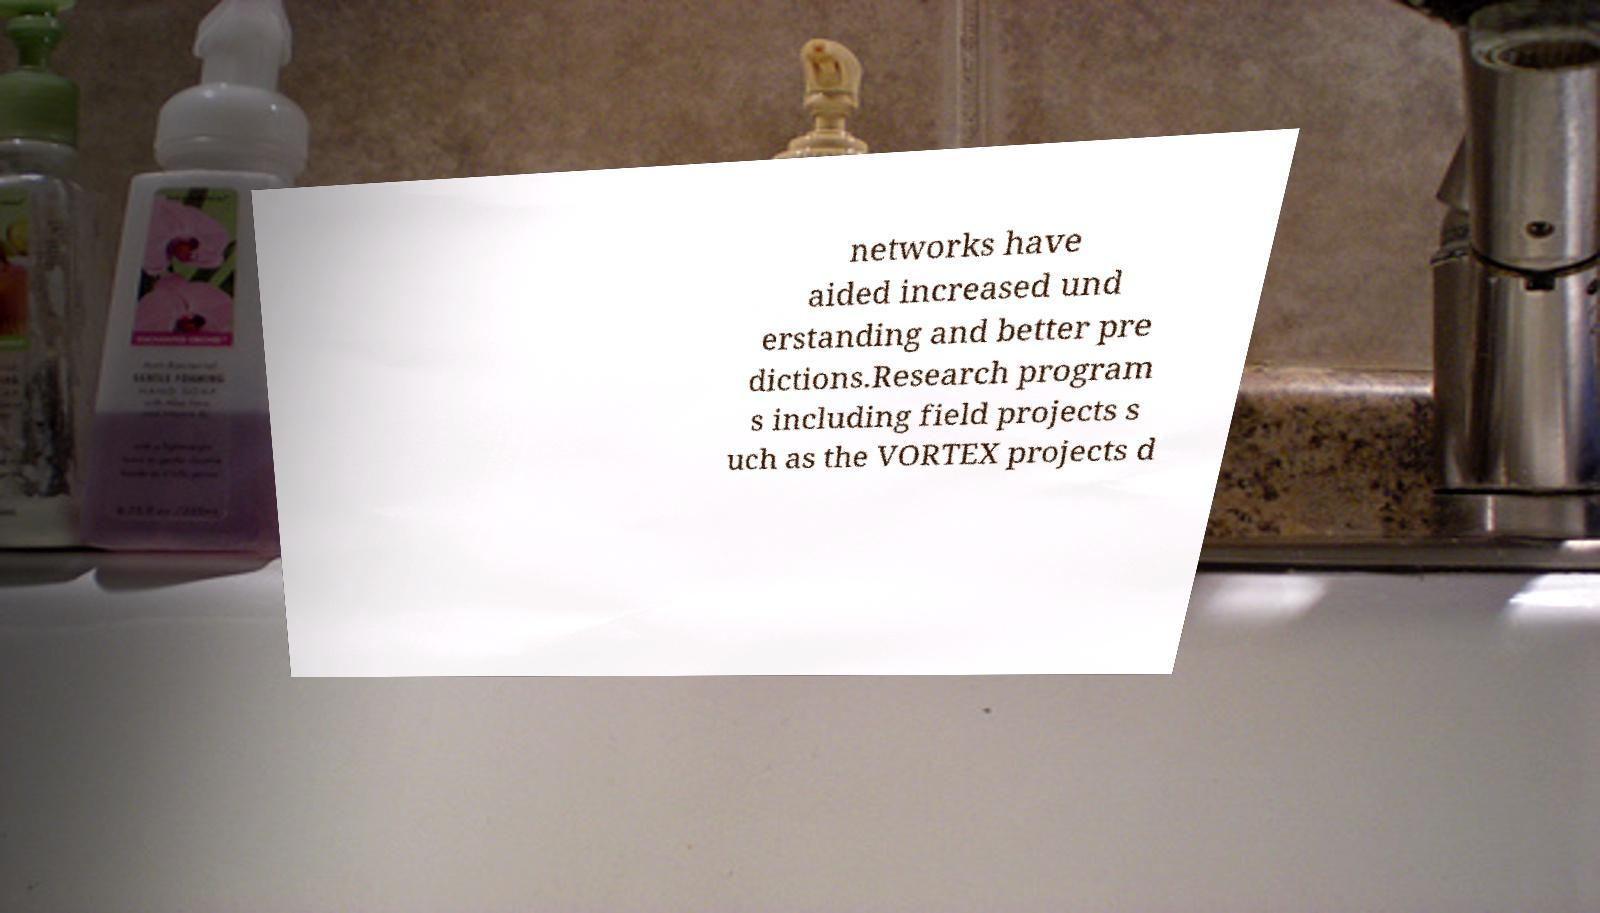I need the written content from this picture converted into text. Can you do that? networks have aided increased und erstanding and better pre dictions.Research program s including field projects s uch as the VORTEX projects d 